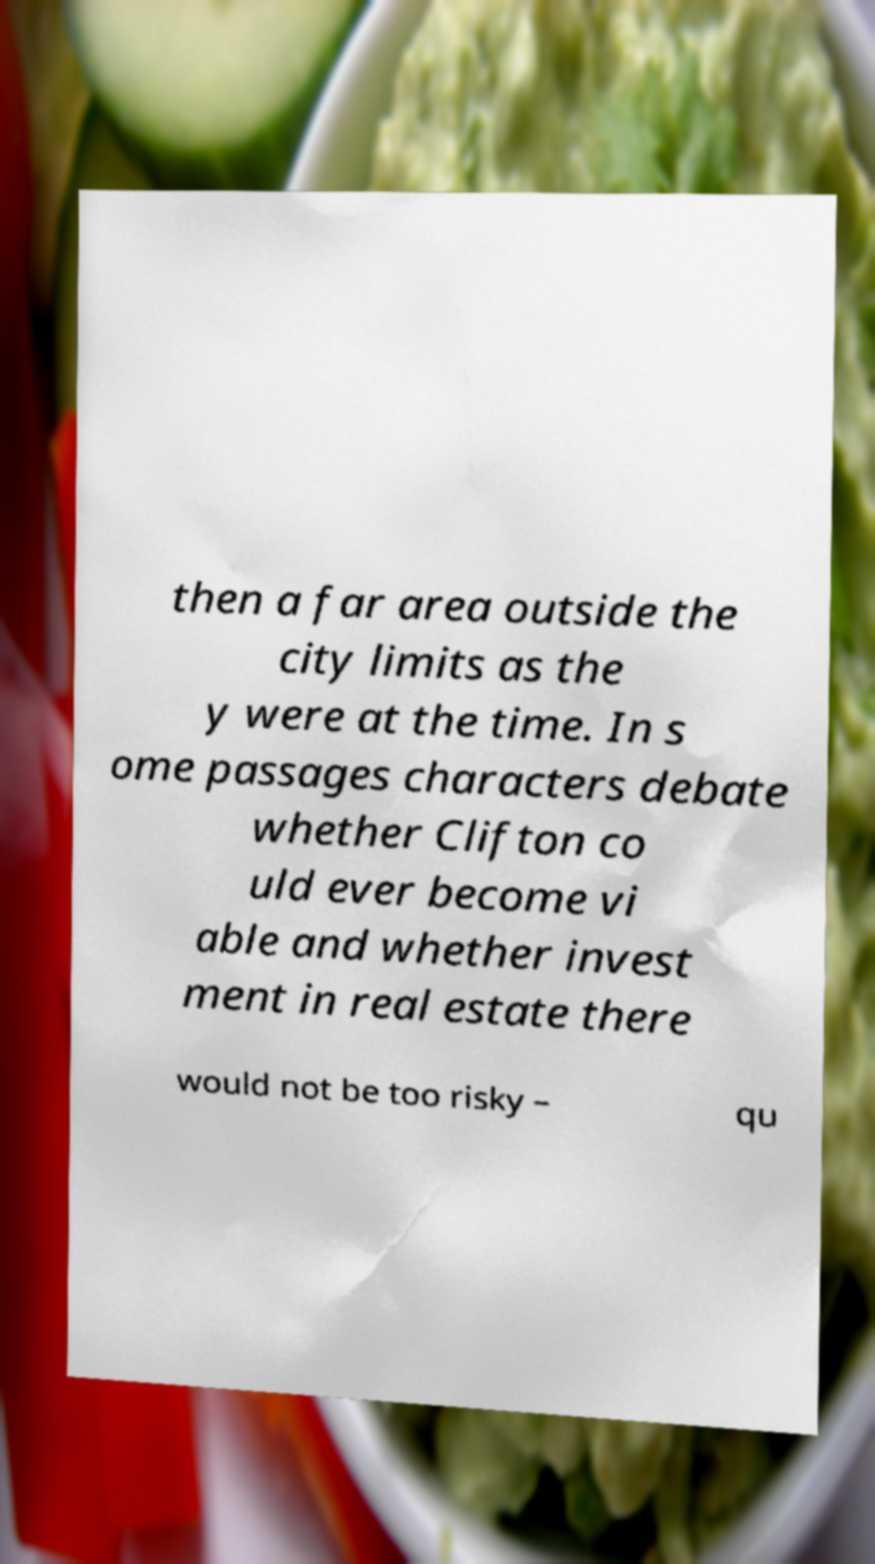Please identify and transcribe the text found in this image. then a far area outside the city limits as the y were at the time. In s ome passages characters debate whether Clifton co uld ever become vi able and whether invest ment in real estate there would not be too risky – qu 